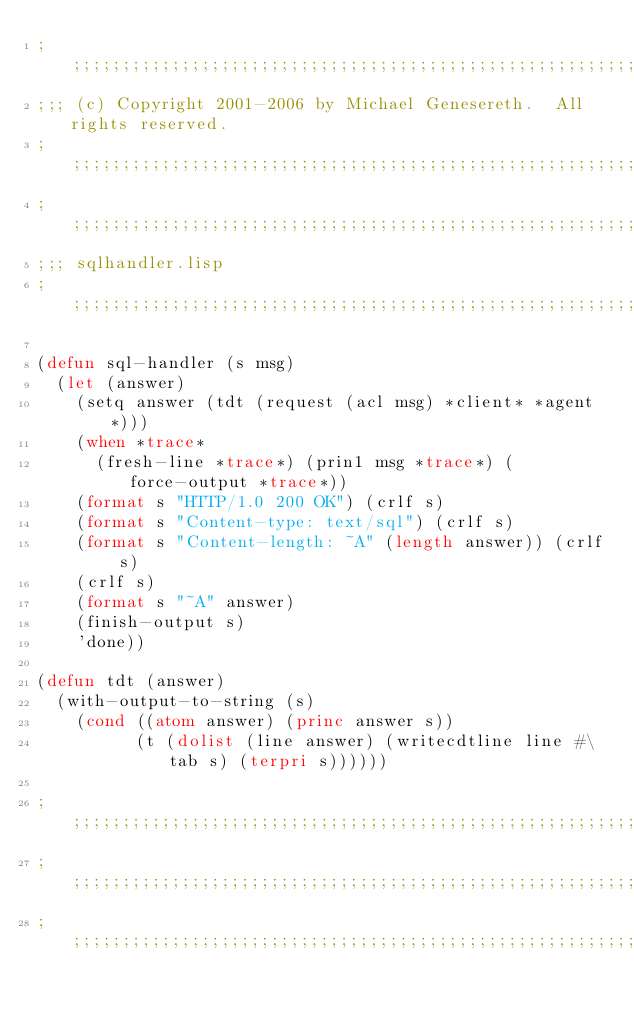<code> <loc_0><loc_0><loc_500><loc_500><_Lisp_>;;;;;;;;;;;;;;;;;;;;;;;;;;;;;;;;;;;;;;;;;;;;;;;;;;;;;;;;;;;;;;;;;;;;;;;;;;;;;;;;
;;; (c) Copyright 2001-2006 by Michael Genesereth.  All rights reserved.
;;;;;;;;;;;;;;;;;;;;;;;;;;;;;;;;;;;;;;;;;;;;;;;;;;;;;;;;;;;;;;;;;;;;;;;;;;;;;;;;
;;;;;;;;;;;;;;;;;;;;;;;;;;;;;;;;;;;;;;;;;;;;;;;;;;;;;;;;;;;;;;;;;;;;;;;;;;;;;;;;
;;; sqlhandler.lisp
;;;;;;;;;;;;;;;;;;;;;;;;;;;;;;;;;;;;;;;;;;;;;;;;;;;;;;;;;;;;;;;;;;;;;;;;;;;;;;;;

(defun sql-handler (s msg)
  (let (answer)
    (setq answer (tdt (request (acl msg) *client* *agent*)))
    (when *trace*
      (fresh-line *trace*) (prin1 msg *trace*) (force-output *trace*))
    (format s "HTTP/1.0 200 OK") (crlf s)
    (format s "Content-type: text/sql") (crlf s)
    (format s "Content-length: ~A" (length answer)) (crlf s)
    (crlf s)
    (format s "~A" answer)
    (finish-output s)
    'done))

(defun tdt (answer)
  (with-output-to-string (s)
    (cond ((atom answer) (princ answer s))
          (t (dolist (line answer) (writecdtline line #\tab s) (terpri s))))))

;;;;;;;;;;;;;;;;;;;;;;;;;;;;;;;;;;;;;;;;;;;;;;;;;;;;;;;;;;;;;;;;;;;;;;;;;;;;;;;;
;;;;;;;;;;;;;;;;;;;;;;;;;;;;;;;;;;;;;;;;;;;;;;;;;;;;;;;;;;;;;;;;;;;;;;;;;;;;;;;;
;;;;;;;;;;;;;;;;;;;;;;;;;;;;;;;;;;;;;;;;;;;;;;;;;;;;;;;;;;;;;;;;;;;;;;;;;;;;;;;;
</code> 